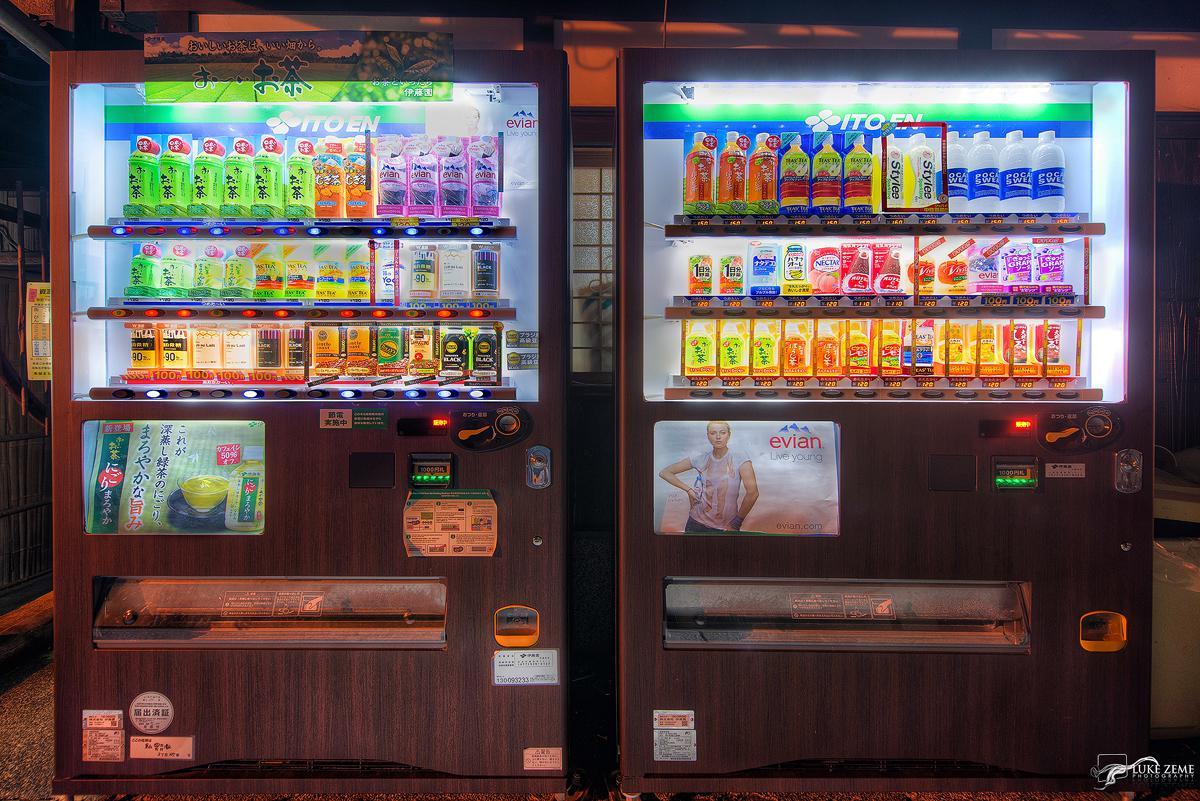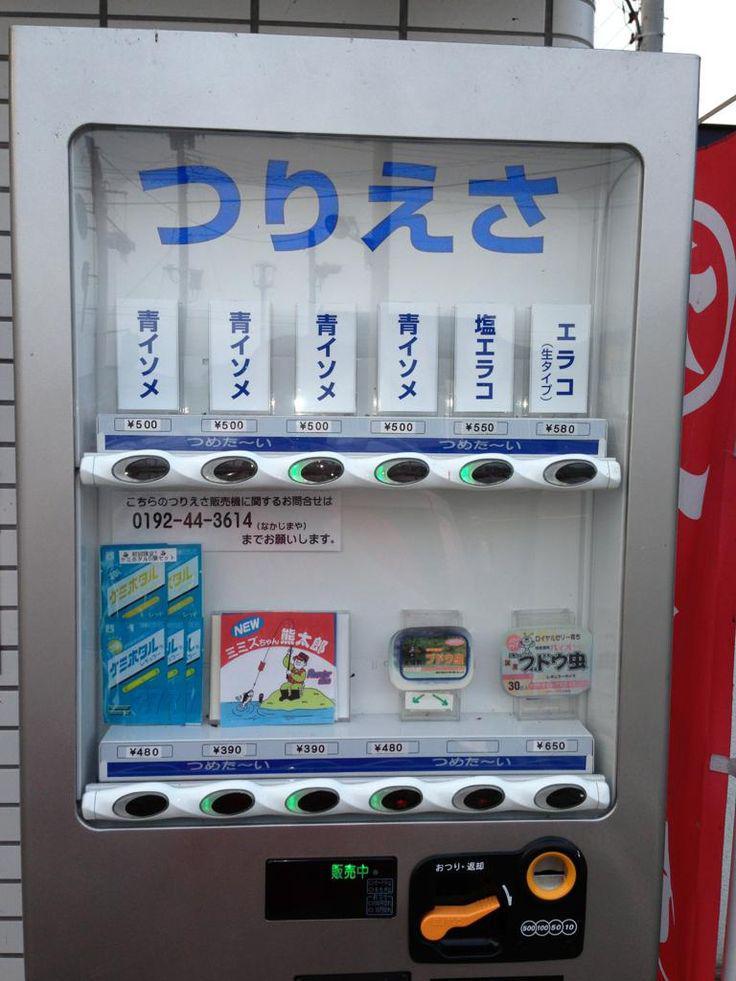The first image is the image on the left, the second image is the image on the right. Analyze the images presented: Is the assertion "There are at least three vending machines that have blue casing." valid? Answer yes or no. No. The first image is the image on the left, the second image is the image on the right. For the images shown, is this caption "An image shows a row of red, white and blue vending machines." true? Answer yes or no. No. 